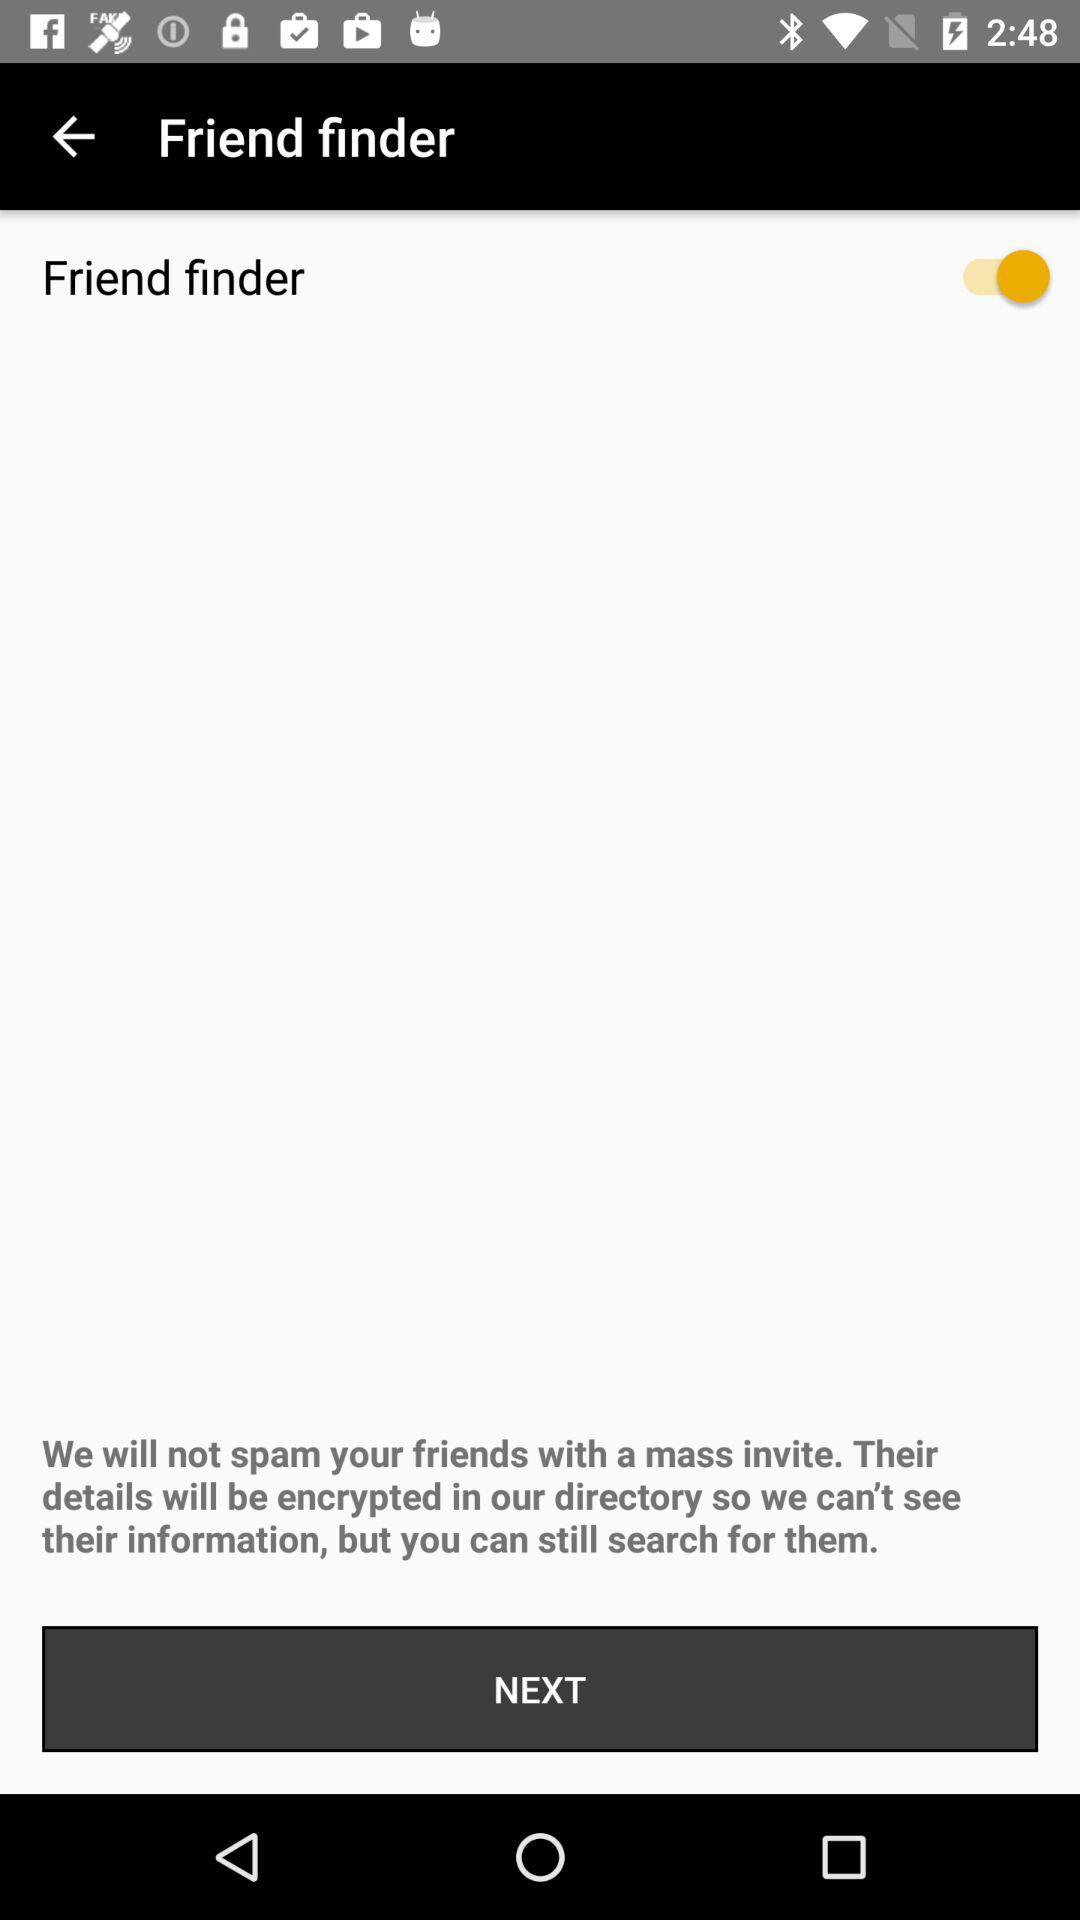What is the status of "Friend finder"? The status is "on". 